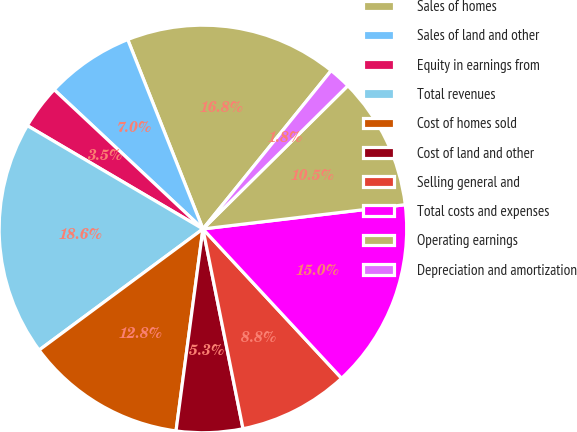Convert chart. <chart><loc_0><loc_0><loc_500><loc_500><pie_chart><fcel>Sales of homes<fcel>Sales of land and other<fcel>Equity in earnings from<fcel>Total revenues<fcel>Cost of homes sold<fcel>Cost of land and other<fcel>Selling general and<fcel>Total costs and expenses<fcel>Operating earnings<fcel>Depreciation and amortization<nl><fcel>16.85%<fcel>7.01%<fcel>3.51%<fcel>18.6%<fcel>12.76%<fcel>5.26%<fcel>8.76%<fcel>14.99%<fcel>10.51%<fcel>1.76%<nl></chart> 